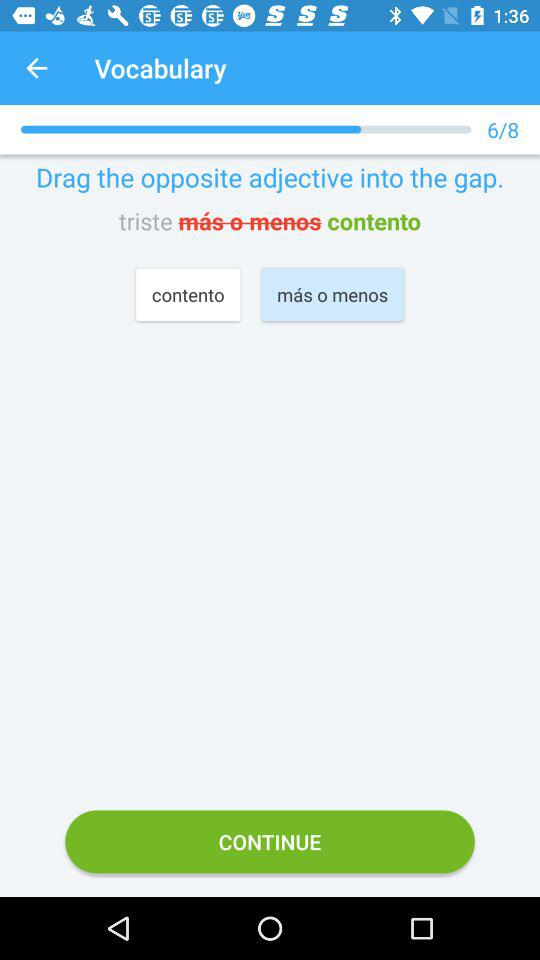What is the total number of questions in "Vocabulary"? The total number of questions is 8. 